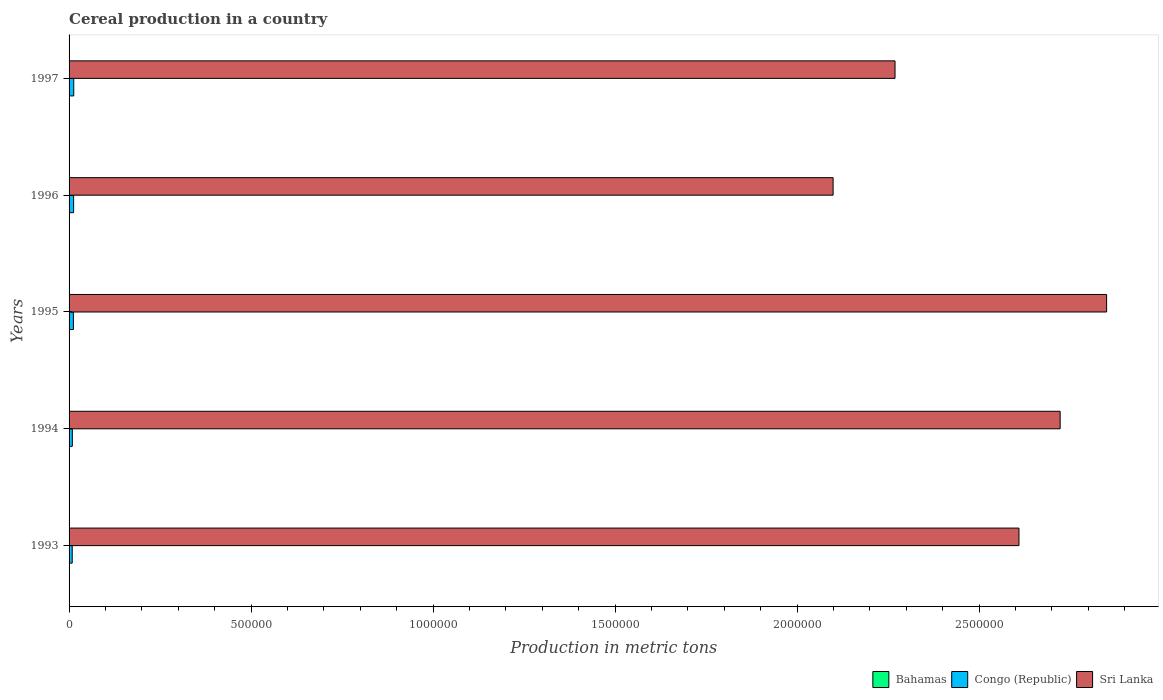How many groups of bars are there?
Offer a terse response. 5. Are the number of bars per tick equal to the number of legend labels?
Ensure brevity in your answer.  Yes. What is the total cereal production in Congo (Republic) in 1996?
Your response must be concise. 1.25e+04. Across all years, what is the maximum total cereal production in Bahamas?
Your answer should be very brief. 400. Across all years, what is the minimum total cereal production in Bahamas?
Make the answer very short. 312. What is the total total cereal production in Sri Lanka in the graph?
Keep it short and to the point. 1.25e+07. What is the difference between the total cereal production in Sri Lanka in 1994 and that in 1996?
Your response must be concise. 6.24e+05. What is the difference between the total cereal production in Sri Lanka in 1994 and the total cereal production in Congo (Republic) in 1995?
Provide a short and direct response. 2.71e+06. What is the average total cereal production in Sri Lanka per year?
Keep it short and to the point. 2.51e+06. In the year 1994, what is the difference between the total cereal production in Bahamas and total cereal production in Congo (Republic)?
Make the answer very short. -8655. In how many years, is the total cereal production in Bahamas greater than 1000000 metric tons?
Offer a terse response. 0. What is the ratio of the total cereal production in Bahamas in 1993 to that in 1995?
Provide a succinct answer. 1.28. Is the total cereal production in Sri Lanka in 1993 less than that in 1995?
Provide a short and direct response. Yes. What is the difference between the highest and the second highest total cereal production in Congo (Republic)?
Provide a succinct answer. 308. What is the difference between the highest and the lowest total cereal production in Congo (Republic)?
Your answer should be very brief. 4171. In how many years, is the total cereal production in Sri Lanka greater than the average total cereal production in Sri Lanka taken over all years?
Ensure brevity in your answer.  3. What does the 3rd bar from the top in 1996 represents?
Your answer should be very brief. Bahamas. What does the 2nd bar from the bottom in 1994 represents?
Keep it short and to the point. Congo (Republic). How many years are there in the graph?
Provide a short and direct response. 5. Are the values on the major ticks of X-axis written in scientific E-notation?
Your answer should be very brief. No. Does the graph contain any zero values?
Ensure brevity in your answer.  No. Does the graph contain grids?
Make the answer very short. No. How are the legend labels stacked?
Your answer should be compact. Horizontal. What is the title of the graph?
Ensure brevity in your answer.  Cereal production in a country. Does "Brunei Darussalam" appear as one of the legend labels in the graph?
Offer a very short reply. No. What is the label or title of the X-axis?
Provide a short and direct response. Production in metric tons. What is the label or title of the Y-axis?
Provide a short and direct response. Years. What is the Production in metric tons of Congo (Republic) in 1993?
Make the answer very short. 8663. What is the Production in metric tons in Sri Lanka in 1993?
Provide a short and direct response. 2.61e+06. What is the Production in metric tons in Bahamas in 1994?
Keep it short and to the point. 312. What is the Production in metric tons in Congo (Republic) in 1994?
Provide a succinct answer. 8967. What is the Production in metric tons of Sri Lanka in 1994?
Give a very brief answer. 2.72e+06. What is the Production in metric tons of Bahamas in 1995?
Your answer should be very brief. 312. What is the Production in metric tons in Congo (Republic) in 1995?
Your answer should be compact. 1.18e+04. What is the Production in metric tons in Sri Lanka in 1995?
Provide a short and direct response. 2.85e+06. What is the Production in metric tons in Bahamas in 1996?
Keep it short and to the point. 312. What is the Production in metric tons of Congo (Republic) in 1996?
Your answer should be very brief. 1.25e+04. What is the Production in metric tons in Sri Lanka in 1996?
Your response must be concise. 2.10e+06. What is the Production in metric tons of Bahamas in 1997?
Ensure brevity in your answer.  348. What is the Production in metric tons in Congo (Republic) in 1997?
Offer a very short reply. 1.28e+04. What is the Production in metric tons in Sri Lanka in 1997?
Your response must be concise. 2.27e+06. Across all years, what is the maximum Production in metric tons of Congo (Republic)?
Offer a terse response. 1.28e+04. Across all years, what is the maximum Production in metric tons in Sri Lanka?
Provide a succinct answer. 2.85e+06. Across all years, what is the minimum Production in metric tons in Bahamas?
Give a very brief answer. 312. Across all years, what is the minimum Production in metric tons in Congo (Republic)?
Provide a succinct answer. 8663. Across all years, what is the minimum Production in metric tons of Sri Lanka?
Offer a terse response. 2.10e+06. What is the total Production in metric tons in Bahamas in the graph?
Offer a very short reply. 1684. What is the total Production in metric tons in Congo (Republic) in the graph?
Provide a short and direct response. 5.48e+04. What is the total Production in metric tons of Sri Lanka in the graph?
Your response must be concise. 1.25e+07. What is the difference between the Production in metric tons in Bahamas in 1993 and that in 1994?
Your answer should be compact. 88. What is the difference between the Production in metric tons of Congo (Republic) in 1993 and that in 1994?
Keep it short and to the point. -304. What is the difference between the Production in metric tons in Sri Lanka in 1993 and that in 1994?
Your answer should be compact. -1.13e+05. What is the difference between the Production in metric tons in Bahamas in 1993 and that in 1995?
Your answer should be compact. 88. What is the difference between the Production in metric tons in Congo (Republic) in 1993 and that in 1995?
Offer a very short reply. -3186. What is the difference between the Production in metric tons of Sri Lanka in 1993 and that in 1995?
Provide a short and direct response. -2.41e+05. What is the difference between the Production in metric tons of Congo (Republic) in 1993 and that in 1996?
Offer a very short reply. -3863. What is the difference between the Production in metric tons in Sri Lanka in 1993 and that in 1996?
Ensure brevity in your answer.  5.11e+05. What is the difference between the Production in metric tons of Congo (Republic) in 1993 and that in 1997?
Make the answer very short. -4171. What is the difference between the Production in metric tons of Sri Lanka in 1993 and that in 1997?
Your answer should be very brief. 3.40e+05. What is the difference between the Production in metric tons of Congo (Republic) in 1994 and that in 1995?
Ensure brevity in your answer.  -2882. What is the difference between the Production in metric tons in Sri Lanka in 1994 and that in 1995?
Offer a very short reply. -1.28e+05. What is the difference between the Production in metric tons of Bahamas in 1994 and that in 1996?
Ensure brevity in your answer.  0. What is the difference between the Production in metric tons in Congo (Republic) in 1994 and that in 1996?
Your response must be concise. -3559. What is the difference between the Production in metric tons in Sri Lanka in 1994 and that in 1996?
Your response must be concise. 6.24e+05. What is the difference between the Production in metric tons in Bahamas in 1994 and that in 1997?
Keep it short and to the point. -36. What is the difference between the Production in metric tons of Congo (Republic) in 1994 and that in 1997?
Provide a short and direct response. -3867. What is the difference between the Production in metric tons of Sri Lanka in 1994 and that in 1997?
Your answer should be very brief. 4.54e+05. What is the difference between the Production in metric tons in Bahamas in 1995 and that in 1996?
Your answer should be very brief. 0. What is the difference between the Production in metric tons of Congo (Republic) in 1995 and that in 1996?
Your answer should be compact. -677. What is the difference between the Production in metric tons of Sri Lanka in 1995 and that in 1996?
Keep it short and to the point. 7.51e+05. What is the difference between the Production in metric tons in Bahamas in 1995 and that in 1997?
Provide a succinct answer. -36. What is the difference between the Production in metric tons of Congo (Republic) in 1995 and that in 1997?
Offer a terse response. -985. What is the difference between the Production in metric tons in Sri Lanka in 1995 and that in 1997?
Your answer should be compact. 5.81e+05. What is the difference between the Production in metric tons in Bahamas in 1996 and that in 1997?
Ensure brevity in your answer.  -36. What is the difference between the Production in metric tons of Congo (Republic) in 1996 and that in 1997?
Provide a succinct answer. -308. What is the difference between the Production in metric tons in Sri Lanka in 1996 and that in 1997?
Your answer should be compact. -1.70e+05. What is the difference between the Production in metric tons of Bahamas in 1993 and the Production in metric tons of Congo (Republic) in 1994?
Offer a very short reply. -8567. What is the difference between the Production in metric tons in Bahamas in 1993 and the Production in metric tons in Sri Lanka in 1994?
Your answer should be very brief. -2.72e+06. What is the difference between the Production in metric tons of Congo (Republic) in 1993 and the Production in metric tons of Sri Lanka in 1994?
Offer a very short reply. -2.71e+06. What is the difference between the Production in metric tons in Bahamas in 1993 and the Production in metric tons in Congo (Republic) in 1995?
Keep it short and to the point. -1.14e+04. What is the difference between the Production in metric tons in Bahamas in 1993 and the Production in metric tons in Sri Lanka in 1995?
Offer a very short reply. -2.85e+06. What is the difference between the Production in metric tons of Congo (Republic) in 1993 and the Production in metric tons of Sri Lanka in 1995?
Ensure brevity in your answer.  -2.84e+06. What is the difference between the Production in metric tons in Bahamas in 1993 and the Production in metric tons in Congo (Republic) in 1996?
Keep it short and to the point. -1.21e+04. What is the difference between the Production in metric tons in Bahamas in 1993 and the Production in metric tons in Sri Lanka in 1996?
Make the answer very short. -2.10e+06. What is the difference between the Production in metric tons of Congo (Republic) in 1993 and the Production in metric tons of Sri Lanka in 1996?
Provide a succinct answer. -2.09e+06. What is the difference between the Production in metric tons in Bahamas in 1993 and the Production in metric tons in Congo (Republic) in 1997?
Offer a very short reply. -1.24e+04. What is the difference between the Production in metric tons of Bahamas in 1993 and the Production in metric tons of Sri Lanka in 1997?
Provide a short and direct response. -2.27e+06. What is the difference between the Production in metric tons of Congo (Republic) in 1993 and the Production in metric tons of Sri Lanka in 1997?
Ensure brevity in your answer.  -2.26e+06. What is the difference between the Production in metric tons in Bahamas in 1994 and the Production in metric tons in Congo (Republic) in 1995?
Ensure brevity in your answer.  -1.15e+04. What is the difference between the Production in metric tons in Bahamas in 1994 and the Production in metric tons in Sri Lanka in 1995?
Provide a succinct answer. -2.85e+06. What is the difference between the Production in metric tons of Congo (Republic) in 1994 and the Production in metric tons of Sri Lanka in 1995?
Your answer should be compact. -2.84e+06. What is the difference between the Production in metric tons of Bahamas in 1994 and the Production in metric tons of Congo (Republic) in 1996?
Give a very brief answer. -1.22e+04. What is the difference between the Production in metric tons of Bahamas in 1994 and the Production in metric tons of Sri Lanka in 1996?
Give a very brief answer. -2.10e+06. What is the difference between the Production in metric tons of Congo (Republic) in 1994 and the Production in metric tons of Sri Lanka in 1996?
Provide a short and direct response. -2.09e+06. What is the difference between the Production in metric tons in Bahamas in 1994 and the Production in metric tons in Congo (Republic) in 1997?
Your answer should be compact. -1.25e+04. What is the difference between the Production in metric tons in Bahamas in 1994 and the Production in metric tons in Sri Lanka in 1997?
Make the answer very short. -2.27e+06. What is the difference between the Production in metric tons of Congo (Republic) in 1994 and the Production in metric tons of Sri Lanka in 1997?
Keep it short and to the point. -2.26e+06. What is the difference between the Production in metric tons of Bahamas in 1995 and the Production in metric tons of Congo (Republic) in 1996?
Your answer should be compact. -1.22e+04. What is the difference between the Production in metric tons in Bahamas in 1995 and the Production in metric tons in Sri Lanka in 1996?
Make the answer very short. -2.10e+06. What is the difference between the Production in metric tons in Congo (Republic) in 1995 and the Production in metric tons in Sri Lanka in 1996?
Provide a succinct answer. -2.09e+06. What is the difference between the Production in metric tons in Bahamas in 1995 and the Production in metric tons in Congo (Republic) in 1997?
Make the answer very short. -1.25e+04. What is the difference between the Production in metric tons of Bahamas in 1995 and the Production in metric tons of Sri Lanka in 1997?
Your answer should be compact. -2.27e+06. What is the difference between the Production in metric tons of Congo (Republic) in 1995 and the Production in metric tons of Sri Lanka in 1997?
Make the answer very short. -2.26e+06. What is the difference between the Production in metric tons of Bahamas in 1996 and the Production in metric tons of Congo (Republic) in 1997?
Your answer should be very brief. -1.25e+04. What is the difference between the Production in metric tons in Bahamas in 1996 and the Production in metric tons in Sri Lanka in 1997?
Offer a terse response. -2.27e+06. What is the difference between the Production in metric tons of Congo (Republic) in 1996 and the Production in metric tons of Sri Lanka in 1997?
Keep it short and to the point. -2.26e+06. What is the average Production in metric tons of Bahamas per year?
Give a very brief answer. 336.8. What is the average Production in metric tons in Congo (Republic) per year?
Your answer should be compact. 1.10e+04. What is the average Production in metric tons of Sri Lanka per year?
Your answer should be very brief. 2.51e+06. In the year 1993, what is the difference between the Production in metric tons of Bahamas and Production in metric tons of Congo (Republic)?
Provide a succinct answer. -8263. In the year 1993, what is the difference between the Production in metric tons of Bahamas and Production in metric tons of Sri Lanka?
Keep it short and to the point. -2.61e+06. In the year 1993, what is the difference between the Production in metric tons of Congo (Republic) and Production in metric tons of Sri Lanka?
Make the answer very short. -2.60e+06. In the year 1994, what is the difference between the Production in metric tons in Bahamas and Production in metric tons in Congo (Republic)?
Offer a very short reply. -8655. In the year 1994, what is the difference between the Production in metric tons of Bahamas and Production in metric tons of Sri Lanka?
Provide a short and direct response. -2.72e+06. In the year 1994, what is the difference between the Production in metric tons of Congo (Republic) and Production in metric tons of Sri Lanka?
Provide a succinct answer. -2.71e+06. In the year 1995, what is the difference between the Production in metric tons in Bahamas and Production in metric tons in Congo (Republic)?
Provide a succinct answer. -1.15e+04. In the year 1995, what is the difference between the Production in metric tons in Bahamas and Production in metric tons in Sri Lanka?
Provide a short and direct response. -2.85e+06. In the year 1995, what is the difference between the Production in metric tons of Congo (Republic) and Production in metric tons of Sri Lanka?
Offer a very short reply. -2.84e+06. In the year 1996, what is the difference between the Production in metric tons of Bahamas and Production in metric tons of Congo (Republic)?
Offer a terse response. -1.22e+04. In the year 1996, what is the difference between the Production in metric tons in Bahamas and Production in metric tons in Sri Lanka?
Make the answer very short. -2.10e+06. In the year 1996, what is the difference between the Production in metric tons of Congo (Republic) and Production in metric tons of Sri Lanka?
Ensure brevity in your answer.  -2.09e+06. In the year 1997, what is the difference between the Production in metric tons of Bahamas and Production in metric tons of Congo (Republic)?
Offer a very short reply. -1.25e+04. In the year 1997, what is the difference between the Production in metric tons in Bahamas and Production in metric tons in Sri Lanka?
Ensure brevity in your answer.  -2.27e+06. In the year 1997, what is the difference between the Production in metric tons of Congo (Republic) and Production in metric tons of Sri Lanka?
Give a very brief answer. -2.26e+06. What is the ratio of the Production in metric tons of Bahamas in 1993 to that in 1994?
Ensure brevity in your answer.  1.28. What is the ratio of the Production in metric tons of Congo (Republic) in 1993 to that in 1994?
Your answer should be compact. 0.97. What is the ratio of the Production in metric tons of Sri Lanka in 1993 to that in 1994?
Provide a succinct answer. 0.96. What is the ratio of the Production in metric tons in Bahamas in 1993 to that in 1995?
Offer a terse response. 1.28. What is the ratio of the Production in metric tons in Congo (Republic) in 1993 to that in 1995?
Ensure brevity in your answer.  0.73. What is the ratio of the Production in metric tons of Sri Lanka in 1993 to that in 1995?
Your response must be concise. 0.92. What is the ratio of the Production in metric tons in Bahamas in 1993 to that in 1996?
Your response must be concise. 1.28. What is the ratio of the Production in metric tons of Congo (Republic) in 1993 to that in 1996?
Keep it short and to the point. 0.69. What is the ratio of the Production in metric tons of Sri Lanka in 1993 to that in 1996?
Offer a very short reply. 1.24. What is the ratio of the Production in metric tons of Bahamas in 1993 to that in 1997?
Your answer should be compact. 1.15. What is the ratio of the Production in metric tons of Congo (Republic) in 1993 to that in 1997?
Provide a short and direct response. 0.68. What is the ratio of the Production in metric tons of Sri Lanka in 1993 to that in 1997?
Offer a terse response. 1.15. What is the ratio of the Production in metric tons in Congo (Republic) in 1994 to that in 1995?
Provide a short and direct response. 0.76. What is the ratio of the Production in metric tons in Sri Lanka in 1994 to that in 1995?
Provide a short and direct response. 0.96. What is the ratio of the Production in metric tons of Bahamas in 1994 to that in 1996?
Provide a succinct answer. 1. What is the ratio of the Production in metric tons in Congo (Republic) in 1994 to that in 1996?
Give a very brief answer. 0.72. What is the ratio of the Production in metric tons in Sri Lanka in 1994 to that in 1996?
Your answer should be very brief. 1.3. What is the ratio of the Production in metric tons in Bahamas in 1994 to that in 1997?
Provide a short and direct response. 0.9. What is the ratio of the Production in metric tons in Congo (Republic) in 1994 to that in 1997?
Your response must be concise. 0.7. What is the ratio of the Production in metric tons of Sri Lanka in 1994 to that in 1997?
Your answer should be very brief. 1.2. What is the ratio of the Production in metric tons in Congo (Republic) in 1995 to that in 1996?
Ensure brevity in your answer.  0.95. What is the ratio of the Production in metric tons of Sri Lanka in 1995 to that in 1996?
Your answer should be very brief. 1.36. What is the ratio of the Production in metric tons in Bahamas in 1995 to that in 1997?
Keep it short and to the point. 0.9. What is the ratio of the Production in metric tons of Congo (Republic) in 1995 to that in 1997?
Offer a terse response. 0.92. What is the ratio of the Production in metric tons of Sri Lanka in 1995 to that in 1997?
Keep it short and to the point. 1.26. What is the ratio of the Production in metric tons of Bahamas in 1996 to that in 1997?
Your answer should be very brief. 0.9. What is the ratio of the Production in metric tons in Congo (Republic) in 1996 to that in 1997?
Make the answer very short. 0.98. What is the ratio of the Production in metric tons in Sri Lanka in 1996 to that in 1997?
Make the answer very short. 0.93. What is the difference between the highest and the second highest Production in metric tons of Congo (Republic)?
Ensure brevity in your answer.  308. What is the difference between the highest and the second highest Production in metric tons in Sri Lanka?
Make the answer very short. 1.28e+05. What is the difference between the highest and the lowest Production in metric tons of Congo (Republic)?
Your response must be concise. 4171. What is the difference between the highest and the lowest Production in metric tons in Sri Lanka?
Provide a succinct answer. 7.51e+05. 